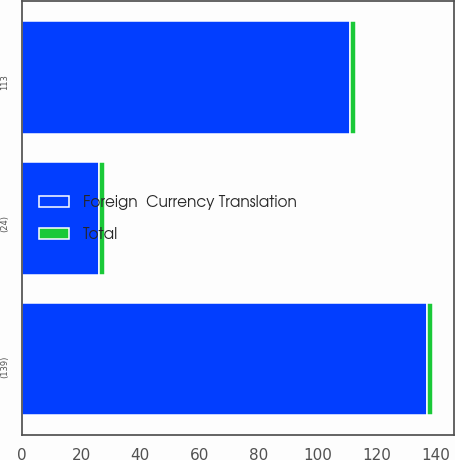Convert chart to OTSL. <chart><loc_0><loc_0><loc_500><loc_500><stacked_bar_chart><ecel><fcel>(139)<fcel>(24)<fcel>113<nl><fcel>Total<fcel>2<fcel>2<fcel>2<nl><fcel>Foreign  Currency Translation<fcel>137<fcel>26<fcel>111<nl></chart> 